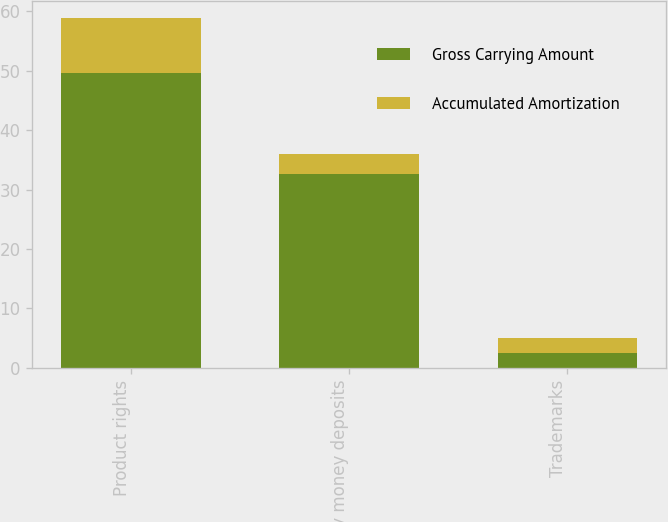<chart> <loc_0><loc_0><loc_500><loc_500><stacked_bar_chart><ecel><fcel>Product rights<fcel>Key money deposits<fcel>Trademarks<nl><fcel>Gross Carrying Amount<fcel>49.6<fcel>32.7<fcel>2.5<nl><fcel>Accumulated Amortization<fcel>9.2<fcel>3.3<fcel>2.5<nl></chart> 